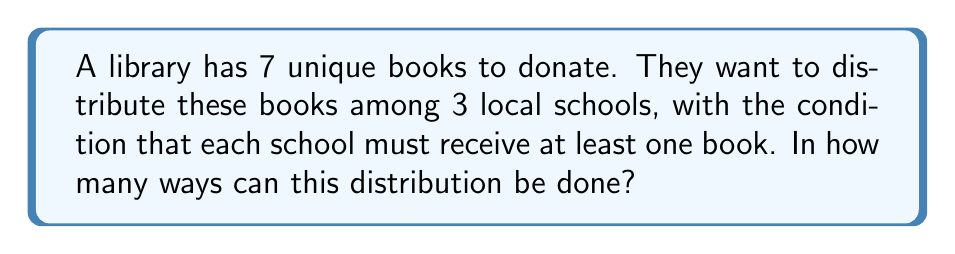Solve this math problem. Let's approach this step-by-step using the concept of Stirling numbers of the second kind and the multiplication principle:

1) First, we need to consider how many ways we can partition 7 distinct books into 3 non-empty sets. This is given by the Stirling number of the second kind, denoted as $\stirling{7}{3}$.

2) The formula for this Stirling number is:

   $$\stirling{7}{3} = \frac{1}{3!}\sum_{i=0}^3 (-1)^i \binom{3}{i}(3-i)^7$$

3) Expanding this:
   $$\stirling{7}{3} = \frac{1}{6}[(3^7) - 3(2^7) + 3(1^7) - 0]$$
   $$= \frac{1}{6}[2187 - 3(128) + 3 - 0]$$
   $$= \frac{1}{6}[2187 - 384 + 3]$$
   $$= \frac{1806}{6} = 301$$

4) However, this only gives us the number of ways to partition the books. We also need to consider how these partitions can be assigned to the 3 schools.

5) For each partition, we have 3! = 6 ways to assign the sets to the schools.

6) Therefore, the total number of ways to distribute the books is:

   $$301 \times 6 = 1806$$
Answer: 1806 